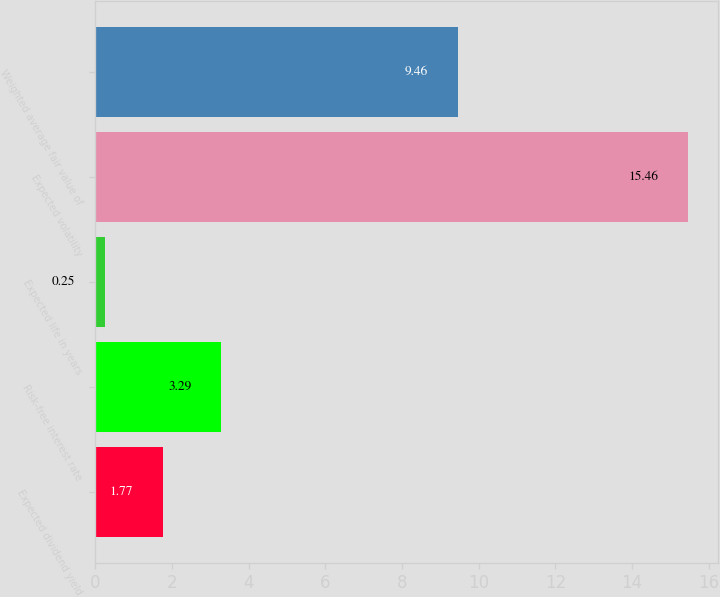Convert chart. <chart><loc_0><loc_0><loc_500><loc_500><bar_chart><fcel>Expected dividend yield<fcel>Risk-free interest rate<fcel>Expected life in years<fcel>Expected volatility<fcel>Weighted average fair value of<nl><fcel>1.77<fcel>3.29<fcel>0.25<fcel>15.46<fcel>9.46<nl></chart> 